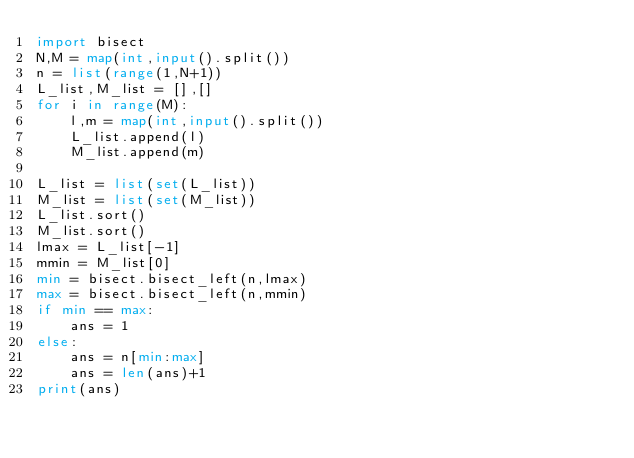Convert code to text. <code><loc_0><loc_0><loc_500><loc_500><_Python_>import bisect
N,M = map(int,input().split())
n = list(range(1,N+1))
L_list,M_list = [],[]
for i in range(M):
    l,m = map(int,input().split())
    L_list.append(l)
    M_list.append(m)

L_list = list(set(L_list))
M_list = list(set(M_list))
L_list.sort()
M_list.sort()
lmax = L_list[-1]
mmin = M_list[0]
min = bisect.bisect_left(n,lmax)
max = bisect.bisect_left(n,mmin)
if min == max:
    ans = 1
else:
    ans = n[min:max]
    ans = len(ans)+1
print(ans)
</code> 